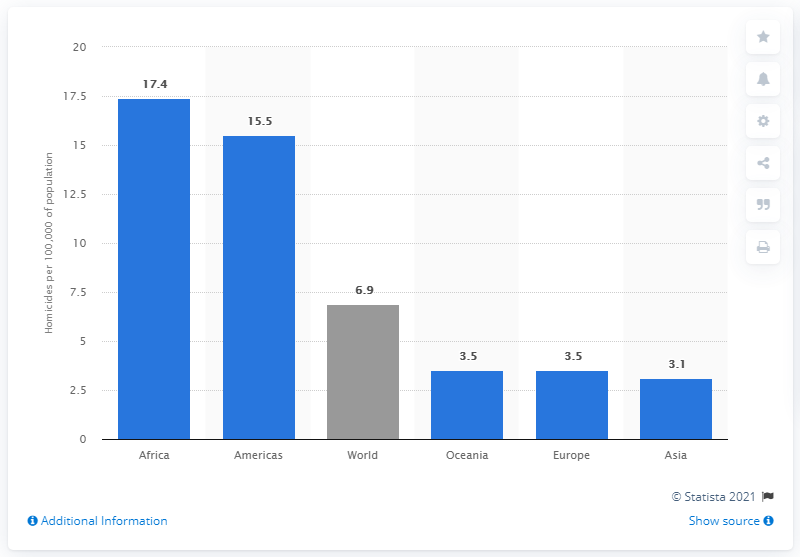Outline some significant characteristics in this image. In 2010, the homicide rate in Africa was 17.4 per 100,000 population. 